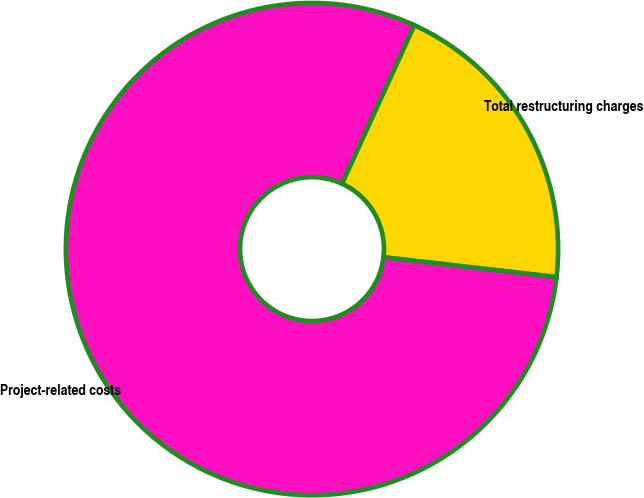Convert chart to OTSL. <chart><loc_0><loc_0><loc_500><loc_500><pie_chart><fcel>Total restructuring charges<fcel>Project-related costs<nl><fcel>20.0%<fcel>80.0%<nl></chart> 